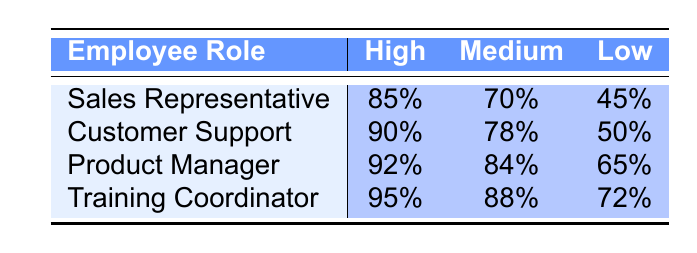What is the training completion rate for Sales Representatives with high product knowledge? According to the table, the training completion rate for Sales Representatives with high product knowledge is explicitly stated as 85%.
Answer: 85% Which employee role has the lowest completion rate for low product knowledge? By looking at the table, the completion rates for low product knowledge are 45% for Sales Representatives, 50% for Customer Support, 65% for Product Managers, and 72% for Training Coordinators. The lowest is 45% for Sales Representatives.
Answer: Sales Representative What is the average training completion rate for the Training Coordinator across all product knowledge evaluations? To find the average, we take the sum of completion rates for the Training Coordinator (95% + 88% + 72%) which equals 255%. We then divide by the number of evaluations, which is 3. So, the average is 255% / 3 = 85%.
Answer: 85% Is the completion rate for Customer Support with medium product knowledge greater than that of Product Managers with low product knowledge? The completion rate for Customer Support with medium product knowledge is 78%, while for Product Managers with low product knowledge, it is 65%. Since 78% is greater than 65%, the answer is yes.
Answer: Yes What is the difference between the highest and lowest training completion rates for high product knowledge across all roles? The highest completion rate for high product knowledge is 95% (Training Coordinator) and the lowest is 85% (Sales Representative). To find the difference, we subtract the lowest from the highest: 95% - 85% = 10%.
Answer: 10% What percentage of employees in the table have a completion rate of at least 80% for medium product knowledge? The completion rates for medium product knowledge are 70% (Sales Representative), 78% (Customer Support), 84% (Product Manager), and 88% (Training Coordinator). Out of these, 84% and 88% are the only two rates that meet the criteria. Therefore, it is 2 out of 4 roles, which is 50%.
Answer: 50% Does any employee role have a completion rate lower than 50% for any product knowledge evaluation? Checking the table, the lowest completion rate listed is 45% for Sales Representatives with low product knowledge. Therefore, the answer is yes.
Answer: Yes What is the overall highest training completion rate across all employee roles and product knowledge evaluations? By reviewing the data, the highest completion rate is 95%, which pertains to the Training Coordinator for high product knowledge.
Answer: 95% 